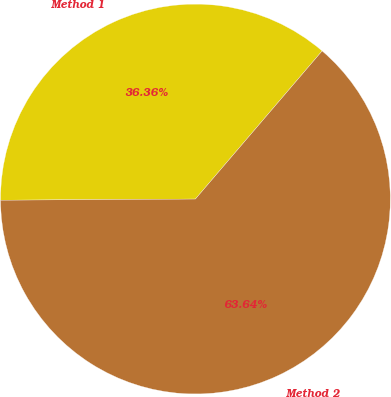Convert chart to OTSL. <chart><loc_0><loc_0><loc_500><loc_500><pie_chart><fcel>Method 1<fcel>Method 2<nl><fcel>36.36%<fcel>63.64%<nl></chart> 